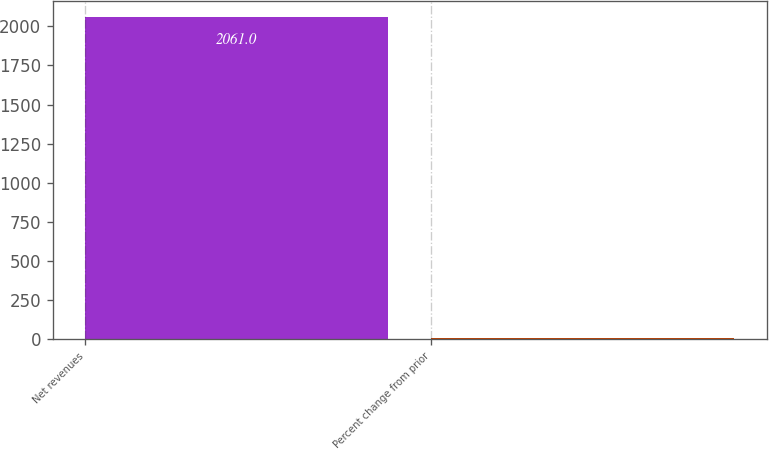Convert chart to OTSL. <chart><loc_0><loc_0><loc_500><loc_500><bar_chart><fcel>Net revenues<fcel>Percent change from prior<nl><fcel>2061<fcel>11<nl></chart> 